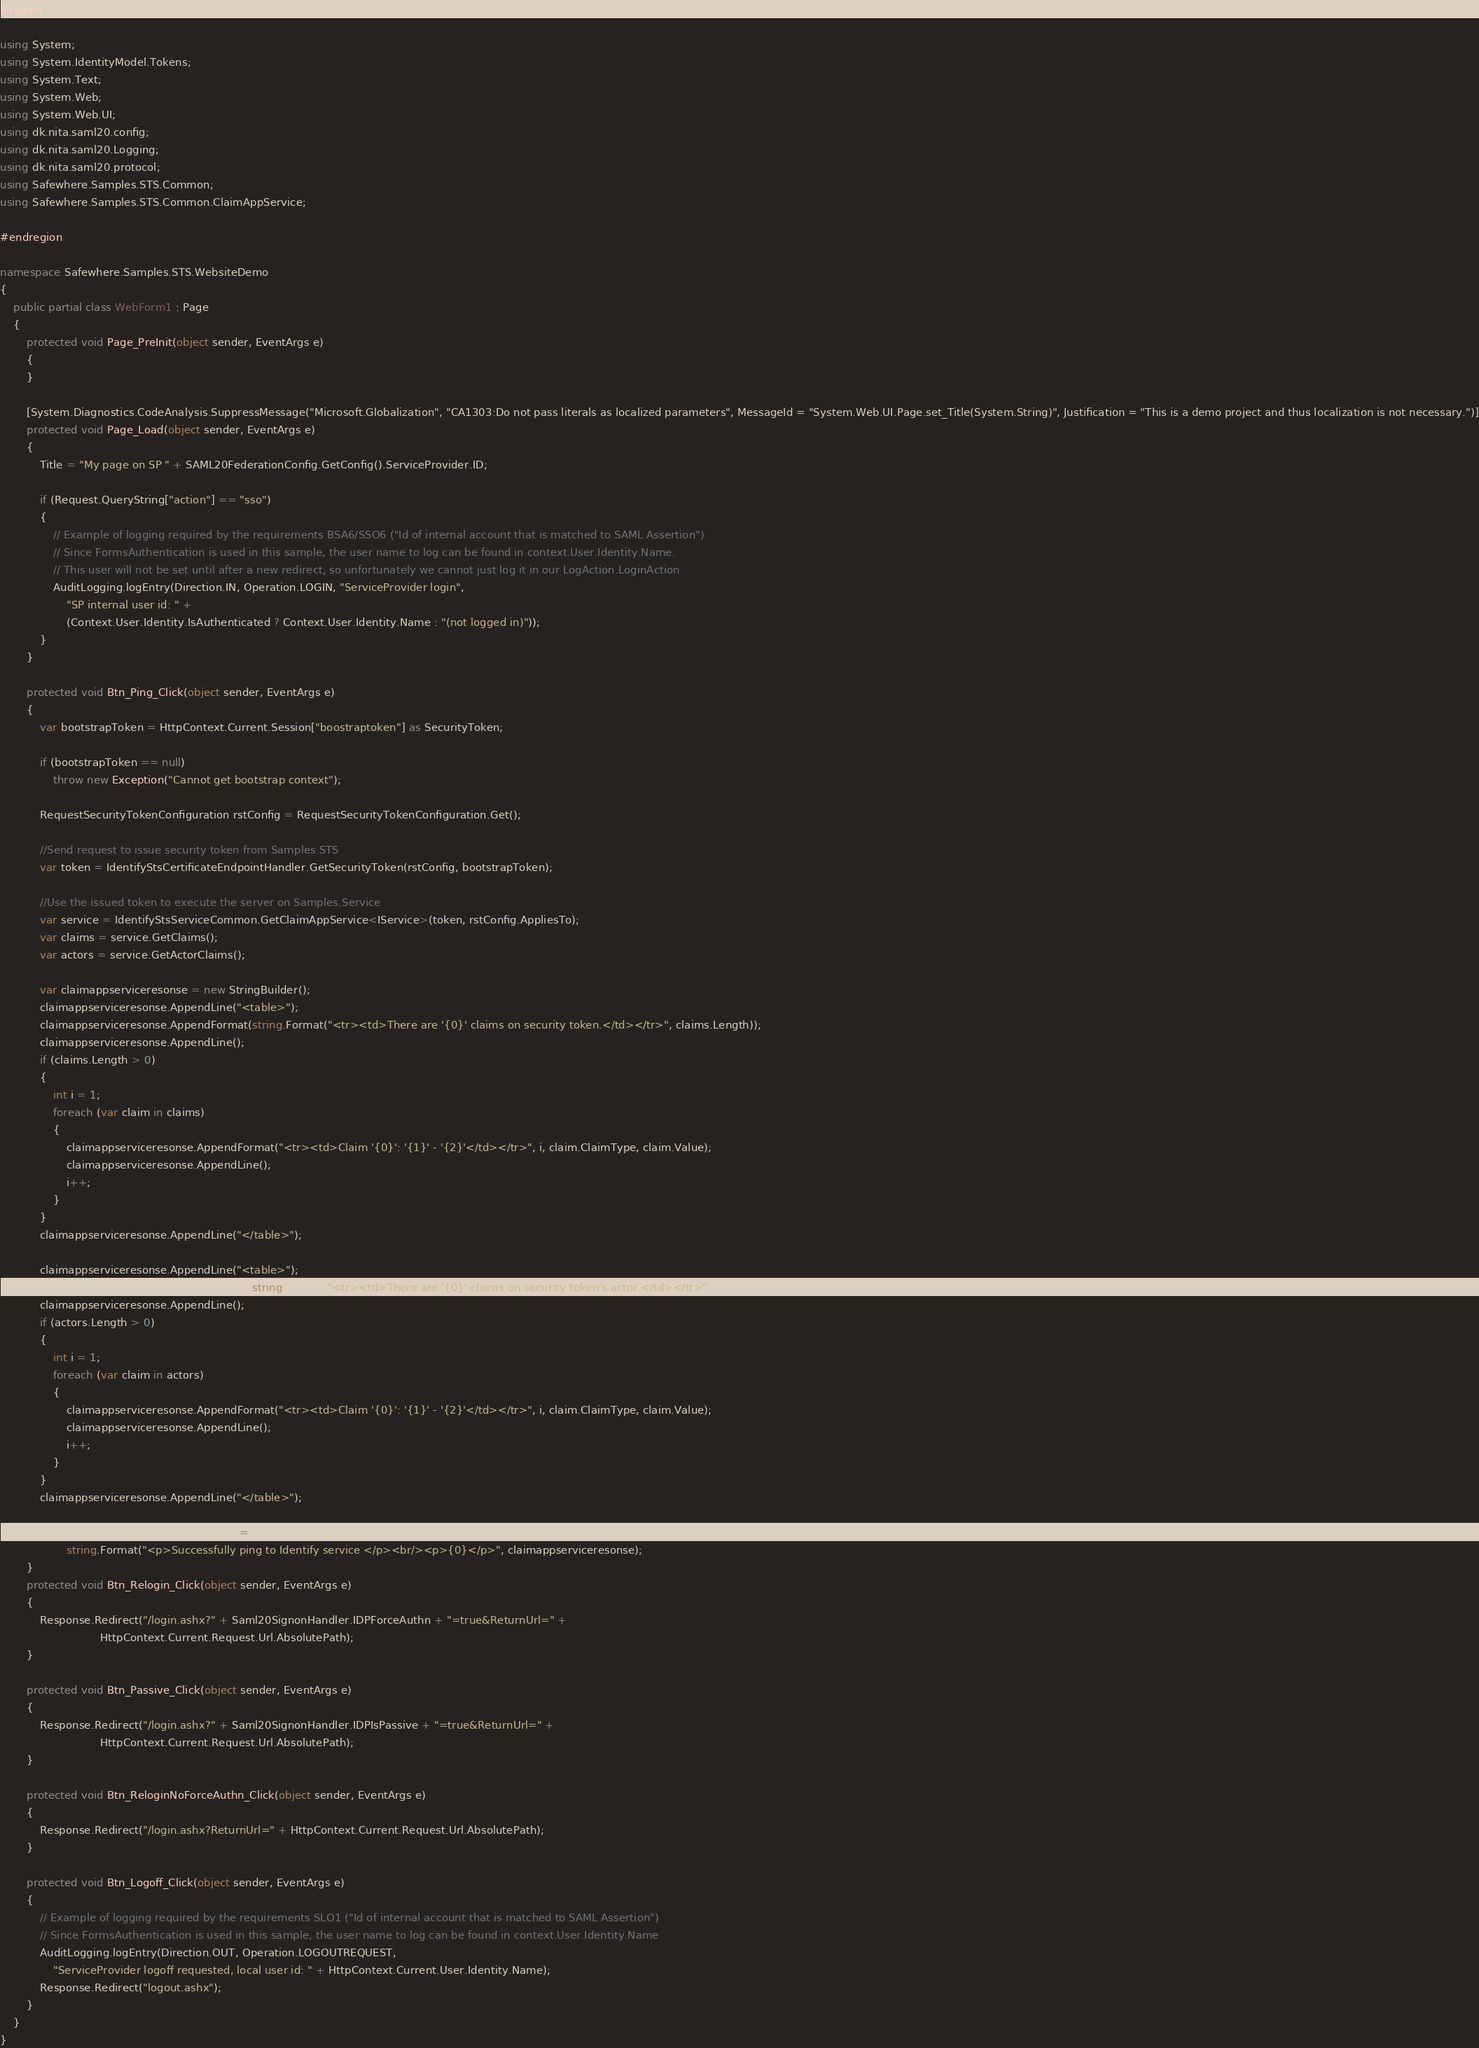<code> <loc_0><loc_0><loc_500><loc_500><_C#_>#region

using System;
using System.IdentityModel.Tokens;
using System.Text;
using System.Web;
using System.Web.UI;
using dk.nita.saml20.config;
using dk.nita.saml20.Logging;
using dk.nita.saml20.protocol;
using Safewhere.Samples.STS.Common;
using Safewhere.Samples.STS.Common.ClaimAppService;

#endregion

namespace Safewhere.Samples.STS.WebsiteDemo
{
    public partial class WebForm1 : Page
    {
        protected void Page_PreInit(object sender, EventArgs e)
        {
        }

        [System.Diagnostics.CodeAnalysis.SuppressMessage("Microsoft.Globalization", "CA1303:Do not pass literals as localized parameters", MessageId = "System.Web.UI.Page.set_Title(System.String)", Justification = "This is a demo project and thus localization is not necessary.")]
        protected void Page_Load(object sender, EventArgs e)
        {
            Title = "My page on SP " + SAML20FederationConfig.GetConfig().ServiceProvider.ID;

            if (Request.QueryString["action"] == "sso")
            {
                // Example of logging required by the requirements BSA6/SSO6 ("Id of internal account that is matched to SAML Assertion")
                // Since FormsAuthentication is used in this sample, the user name to log can be found in context.User.Identity.Name.
                // This user will not be set until after a new redirect, so unfortunately we cannot just log it in our LogAction.LoginAction
                AuditLogging.logEntry(Direction.IN, Operation.LOGIN, "ServiceProvider login",
                    "SP internal user id: " +
                    (Context.User.Identity.IsAuthenticated ? Context.User.Identity.Name : "(not logged in)"));
            }
        }

        protected void Btn_Ping_Click(object sender, EventArgs e)
        {
            var bootstrapToken = HttpContext.Current.Session["boostraptoken"] as SecurityToken;

            if (bootstrapToken == null)
                throw new Exception("Cannot get bootstrap context");

            RequestSecurityTokenConfiguration rstConfig = RequestSecurityTokenConfiguration.Get();

            //Send request to issue security token from Samples.STS
            var token = IdentifyStsCertificateEndpointHandler.GetSecurityToken(rstConfig, bootstrapToken);

            //Use the issued token to execute the server on Samples.Service
            var service = IdentifyStsServiceCommon.GetClaimAppService<IService>(token, rstConfig.AppliesTo);
            var claims = service.GetClaims();
            var actors = service.GetActorClaims();

            var claimappserviceresonse = new StringBuilder();
            claimappserviceresonse.AppendLine("<table>");
            claimappserviceresonse.AppendFormat(string.Format("<tr><td>There are '{0}' claims on security token.</td></tr>", claims.Length));
            claimappserviceresonse.AppendLine();
            if (claims.Length > 0)
            {
                int i = 1;
                foreach (var claim in claims)
                {
                    claimappserviceresonse.AppendFormat("<tr><td>Claim '{0}': '{1}' - '{2}'</td></tr>", i, claim.ClaimType, claim.Value);
                    claimappserviceresonse.AppendLine();
                    i++;
                }
            }
            claimappserviceresonse.AppendLine("</table>");

            claimappserviceresonse.AppendLine("<table>");
            claimappserviceresonse.AppendFormat(string.Format("<tr><td>There are '{0}' claims on security token's actor.</td></tr>", actors.Length));
            claimappserviceresonse.AppendLine();
            if (actors.Length > 0)
            {
                int i = 1;
                foreach (var claim in actors)
                {
                    claimappserviceresonse.AppendFormat("<tr><td>Claim '{0}': '{1}' - '{2}'</td></tr>", i, claim.ClaimType, claim.Value);
                    claimappserviceresonse.AppendLine();
                    i++;
                }
            }
            claimappserviceresonse.AppendLine("</table>");

            ClaimAppServiceResponse.InnerHtml =
                    string.Format("<p>Successfully ping to Identify service </p><br/><p>{0}</p>", claimappserviceresonse);
        }
        protected void Btn_Relogin_Click(object sender, EventArgs e)
        {
            Response.Redirect("/login.ashx?" + Saml20SignonHandler.IDPForceAuthn + "=true&ReturnUrl=" +
                              HttpContext.Current.Request.Url.AbsolutePath);
        }

        protected void Btn_Passive_Click(object sender, EventArgs e)
        {
            Response.Redirect("/login.ashx?" + Saml20SignonHandler.IDPIsPassive + "=true&ReturnUrl=" +
                              HttpContext.Current.Request.Url.AbsolutePath);
        }

        protected void Btn_ReloginNoForceAuthn_Click(object sender, EventArgs e)
        {
            Response.Redirect("/login.ashx?ReturnUrl=" + HttpContext.Current.Request.Url.AbsolutePath);
        }

        protected void Btn_Logoff_Click(object sender, EventArgs e)
        {
            // Example of logging required by the requirements SLO1 ("Id of internal account that is matched to SAML Assertion")
            // Since FormsAuthentication is used in this sample, the user name to log can be found in context.User.Identity.Name
            AuditLogging.logEntry(Direction.OUT, Operation.LOGOUTREQUEST,
                "ServiceProvider logoff requested, local user id: " + HttpContext.Current.User.Identity.Name);
            Response.Redirect("logout.ashx");
        }
    }
}</code> 